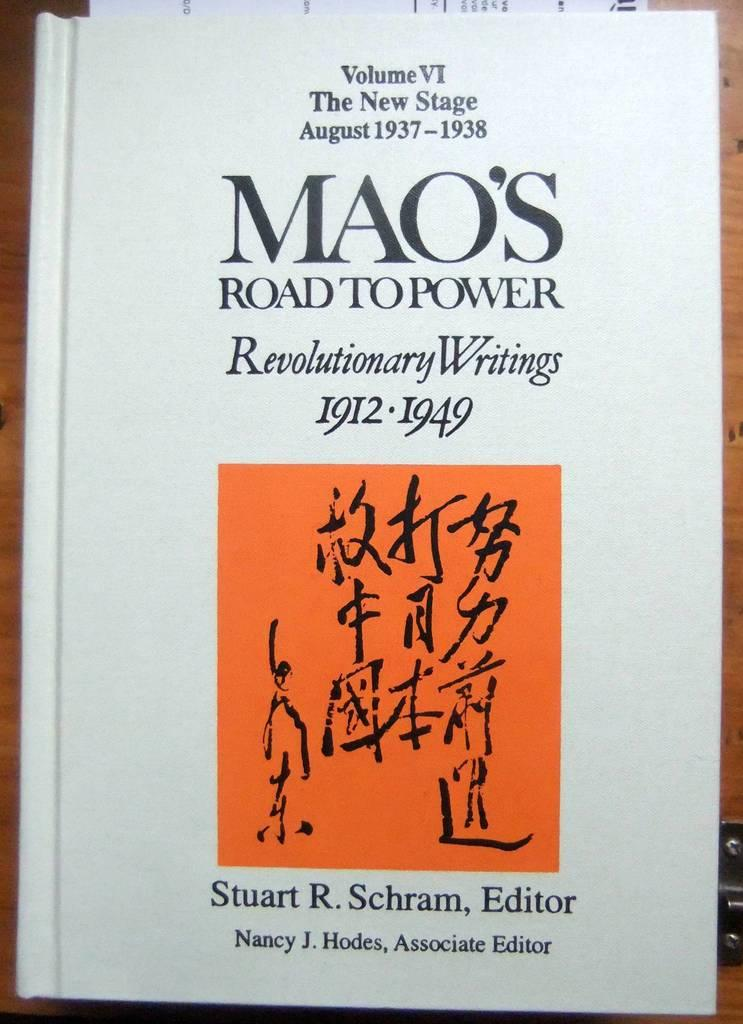<image>
Summarize the visual content of the image. Orange and White Mao's Road to power written on the front sits on a brown surface. 